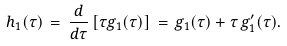<formula> <loc_0><loc_0><loc_500><loc_500>h _ { 1 } ( \tau ) \, = \, \frac { d } { d \tau } \left [ \tau g _ { 1 } ( \tau ) \right ] \, = \, g _ { 1 } ( \tau ) + \tau \, g _ { 1 } ^ { \prime } ( \tau ) .</formula> 